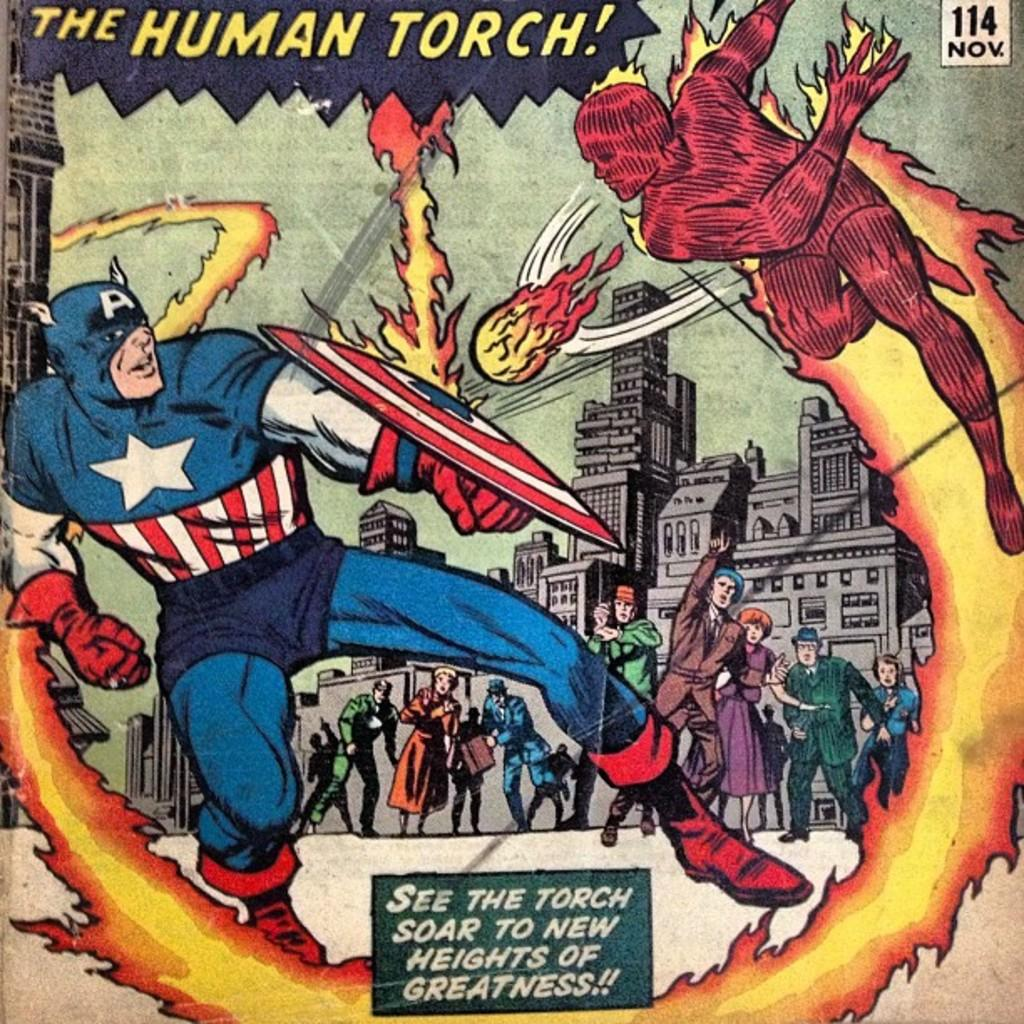<image>
Create a compact narrative representing the image presented. The cover of a DC comic featuring captain america fighting the huiman torch as crowds look on. 